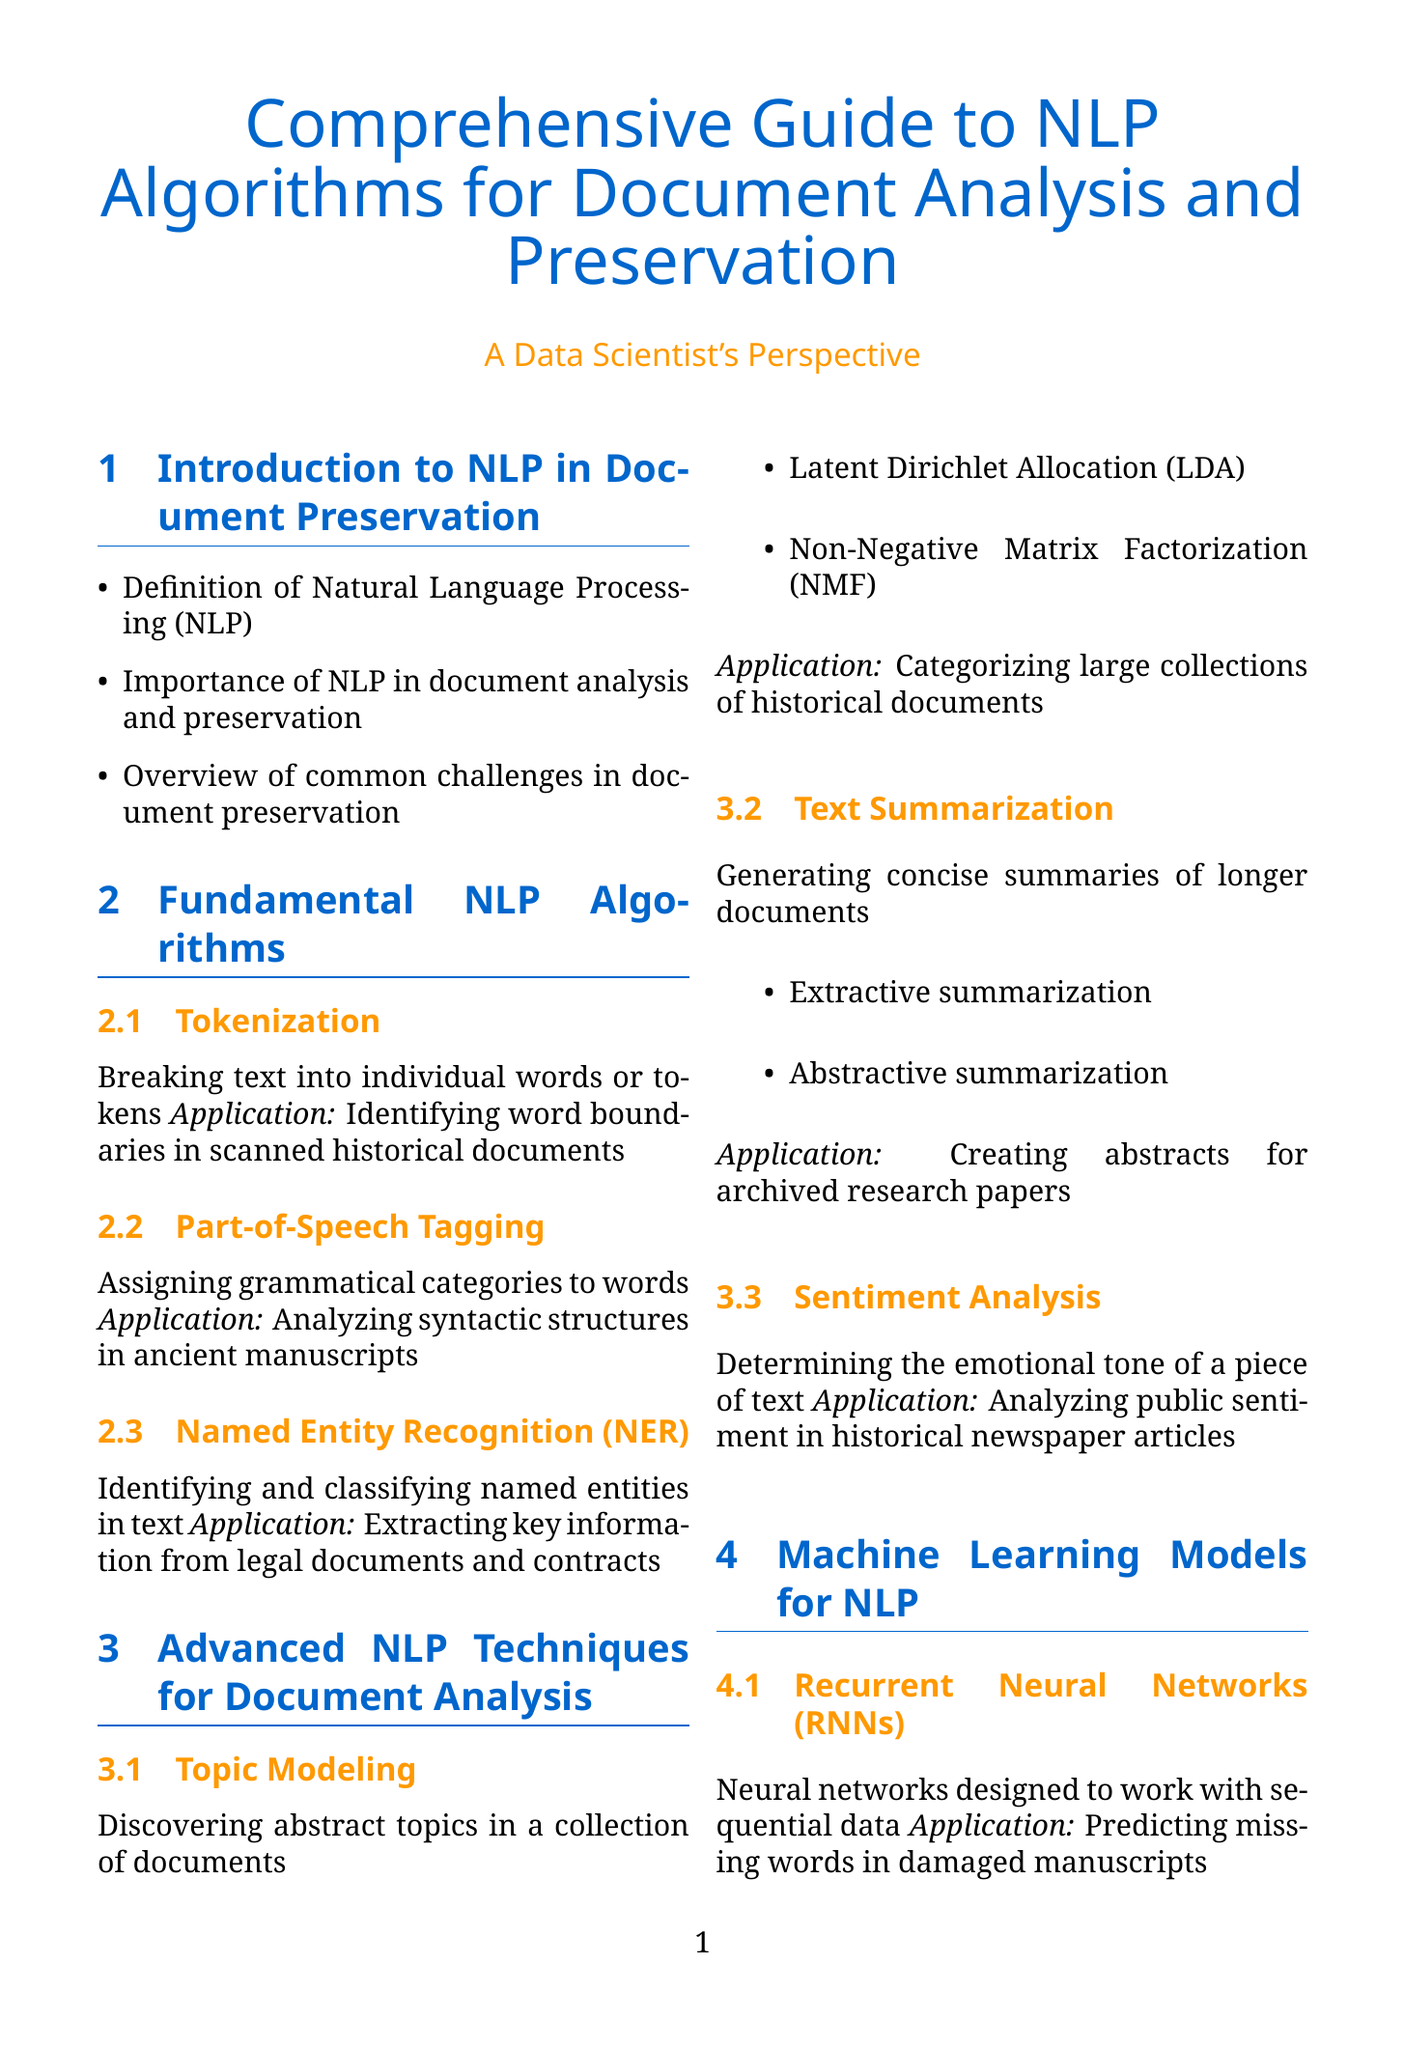What is the main focus of the document? The document is a comprehensive guide aimed at explaining NLP algorithms specifically for document analysis and preservation.
Answer: NLP algorithms for document analysis and preservation What technique is used for converting images of text? The document describes Optical Character Recognition (OCR) as the technique for this purpose.
Answer: Optical Character Recognition (OCR) Which algorithm is used for identifying word boundaries? The algorithm that breaks text into individual words or tokens is tokenization.
Answer: Tokenization What are the two types of summarization mentioned? The document mentions extractive and abstractive summarization as the two types.
Answer: Extractive summarization, Abstractive summarization What role do transformer models play in NLP? Transformer models are attention-based models for processing sequential data, used to improve OCR accuracy.
Answer: Improve OCR accuracy in digitized documents What was the focus of the Vatican Apostolic Library project? The project aimed for large-scale digitization and analysis of historical manuscripts.
Answer: Large-scale digitization and analysis of historical manuscripts How many advanced NLP techniques are discussed in the document? There are three advanced NLP techniques covered: Topic Modeling, Text Summarization, and Sentiment Analysis.
Answer: Three Which machine learning model is designed for sequential data? The Recurrent Neural Networks (RNNs) are the machine learning model designed for sequential data.
Answer: Recurrent Neural Networks (RNNs) What is a challenge in handwriting recognition? A significant challenge in handwriting recognition is the variation in writing styles.
Answer: Variation in writing styles 